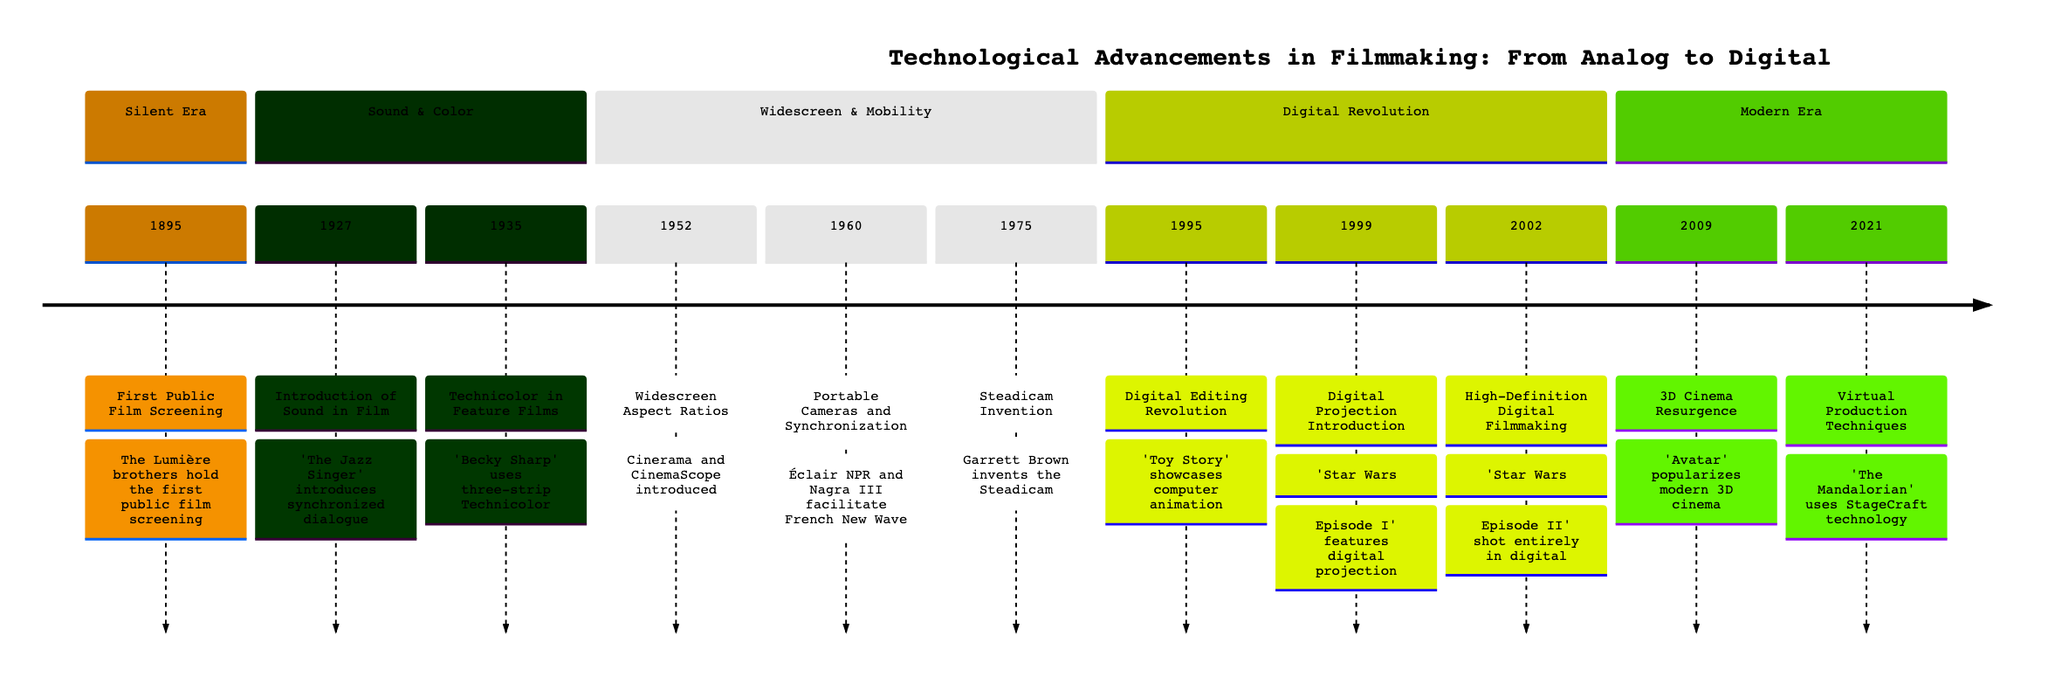What year did the first public film screening occur? Referring to the timeline, the first public film screening is marked in the year 1895. This year is specifically noted as the beginning of cinema with the Lumière brothers' event.
Answer: 1895 Which film introduced synchronized dialogue? The timeline indicates that 'The Jazz Singer' was released in 1927 and is recognized for introducing synchronized dialogue sequences, thus marking the start of 'talkies.'
Answer: 'The Jazz Singer' How many significant events are listed in the timeline? By counting each event mentioned in the timeline, we find a total of 11 significant events regarding technological advancements in filmmaking from analog to digital.
Answer: 11 In what year was Technicolor first utilized in feature films? The timeline states that Technicolor was first introduced in the feature film 'Becky Sharp' in 1935. This year is noted for the innovative use of three-strip Technicolor.
Answer: 1935 What technological advancement in filmmaking was introduced in 2002? According to the timeline, in 2002, 'Star Wars: Episode II – Attack of the Clones' was the first major motion picture to be shot entirely using high-definition digital technology.
Answer: High-Definition Digital Filmmaking What film marked the resurgence of 3D cinema? The timeline specifies that James Cameron's film 'Avatar' released in 2009 is noted for leveraging advanced 3D technology and achieving significant box office success, effectively reviving interest in 3D cinema.
Answer: 'Avatar' Which device was invented to help achieve stabilized shots in 1975? The timeline points out that Garrett Brown invented the Steadicam in 1975, facilitating smooth and stabilized shots, which greatly enriched the visual storytelling in films.
Answer: Steadicam What event related to virtual production techniques happened in 2021? The timeline notes that in 2021, 'The Mandalorian' utilized StageCraft technology, creating virtual sets with LED screens, which transformed traditional filming methods for visual effects-heavy scenes.
Answer: Virtual Production Techniques What transition marked the digital editing revolution in 1995? The timeline highlights that 1995 was marked by the release of 'Toy Story,' the first entirely computer-animated feature film, which showcased the potential of digital editing techniques in filmmaking.
Answer: Digital Editing Revolution 